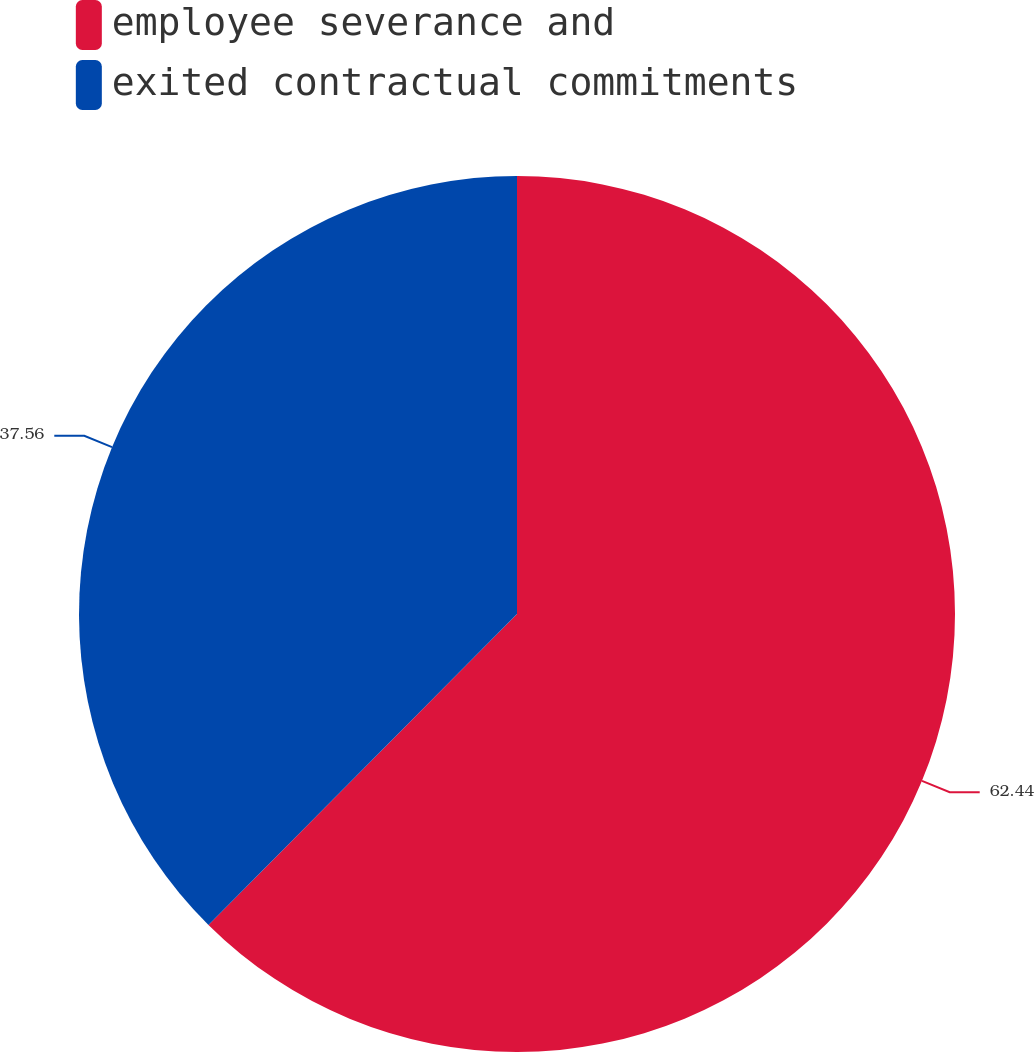Convert chart. <chart><loc_0><loc_0><loc_500><loc_500><pie_chart><fcel>employee severance and<fcel>exited contractual commitments<nl><fcel>62.44%<fcel>37.56%<nl></chart> 